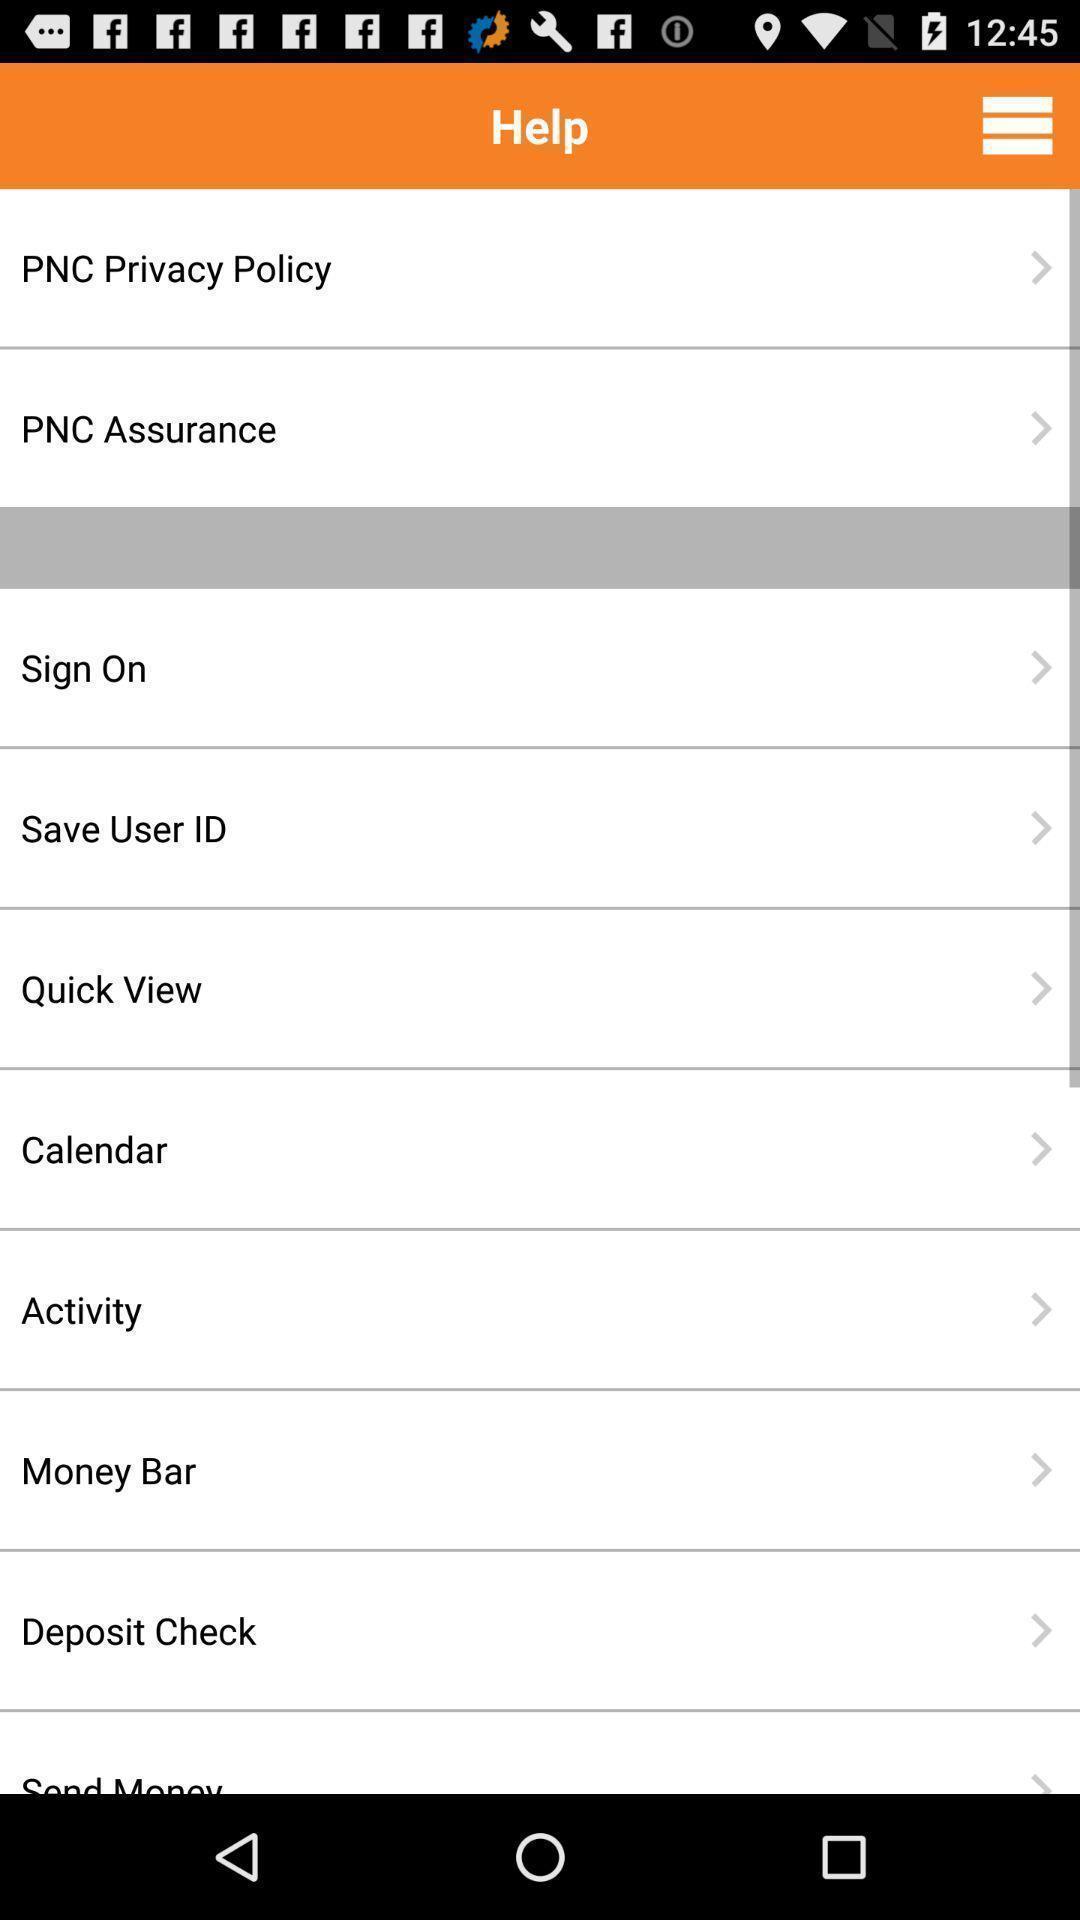Summarize the main components in this picture. Screen displaying multiple options in digital wallet application. 